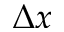Convert formula to latex. <formula><loc_0><loc_0><loc_500><loc_500>\Delta x</formula> 